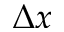Convert formula to latex. <formula><loc_0><loc_0><loc_500><loc_500>\Delta x</formula> 